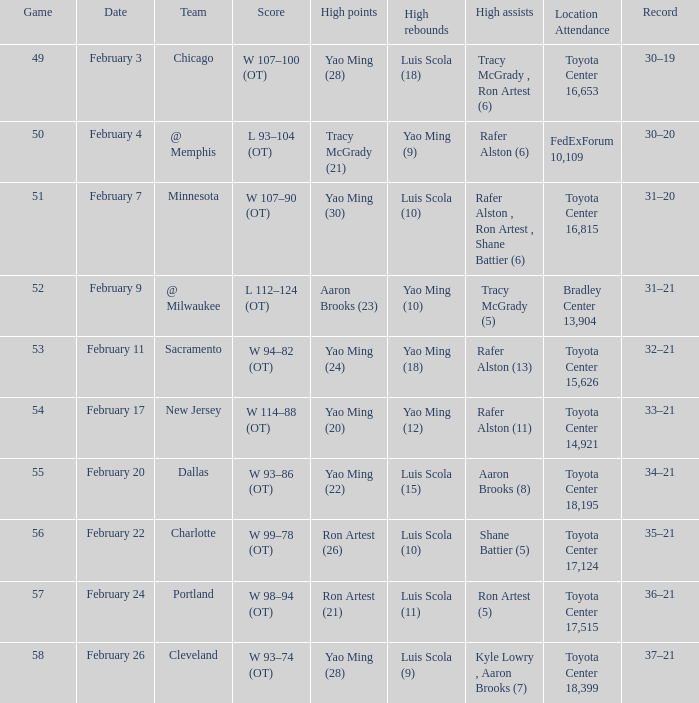Name the record for score of  l 93–104 (ot) 30–20. I'm looking to parse the entire table for insights. Could you assist me with that? {'header': ['Game', 'Date', 'Team', 'Score', 'High points', 'High rebounds', 'High assists', 'Location Attendance', 'Record'], 'rows': [['49', 'February 3', 'Chicago', 'W 107–100 (OT)', 'Yao Ming (28)', 'Luis Scola (18)', 'Tracy McGrady , Ron Artest (6)', 'Toyota Center 16,653', '30–19'], ['50', 'February 4', '@ Memphis', 'L 93–104 (OT)', 'Tracy McGrady (21)', 'Yao Ming (9)', 'Rafer Alston (6)', 'FedExForum 10,109', '30–20'], ['51', 'February 7', 'Minnesota', 'W 107–90 (OT)', 'Yao Ming (30)', 'Luis Scola (10)', 'Rafer Alston , Ron Artest , Shane Battier (6)', 'Toyota Center 16,815', '31–20'], ['52', 'February 9', '@ Milwaukee', 'L 112–124 (OT)', 'Aaron Brooks (23)', 'Yao Ming (10)', 'Tracy McGrady (5)', 'Bradley Center 13,904', '31–21'], ['53', 'February 11', 'Sacramento', 'W 94–82 (OT)', 'Yao Ming (24)', 'Yao Ming (18)', 'Rafer Alston (13)', 'Toyota Center 15,626', '32–21'], ['54', 'February 17', 'New Jersey', 'W 114–88 (OT)', 'Yao Ming (20)', 'Yao Ming (12)', 'Rafer Alston (11)', 'Toyota Center 14,921', '33–21'], ['55', 'February 20', 'Dallas', 'W 93–86 (OT)', 'Yao Ming (22)', 'Luis Scola (15)', 'Aaron Brooks (8)', 'Toyota Center 18,195', '34–21'], ['56', 'February 22', 'Charlotte', 'W 99–78 (OT)', 'Ron Artest (26)', 'Luis Scola (10)', 'Shane Battier (5)', 'Toyota Center 17,124', '35–21'], ['57', 'February 24', 'Portland', 'W 98–94 (OT)', 'Ron Artest (21)', 'Luis Scola (11)', 'Ron Artest (5)', 'Toyota Center 17,515', '36–21'], ['58', 'February 26', 'Cleveland', 'W 93–74 (OT)', 'Yao Ming (28)', 'Luis Scola (9)', 'Kyle Lowry , Aaron Brooks (7)', 'Toyota Center 18,399', '37–21']]} 